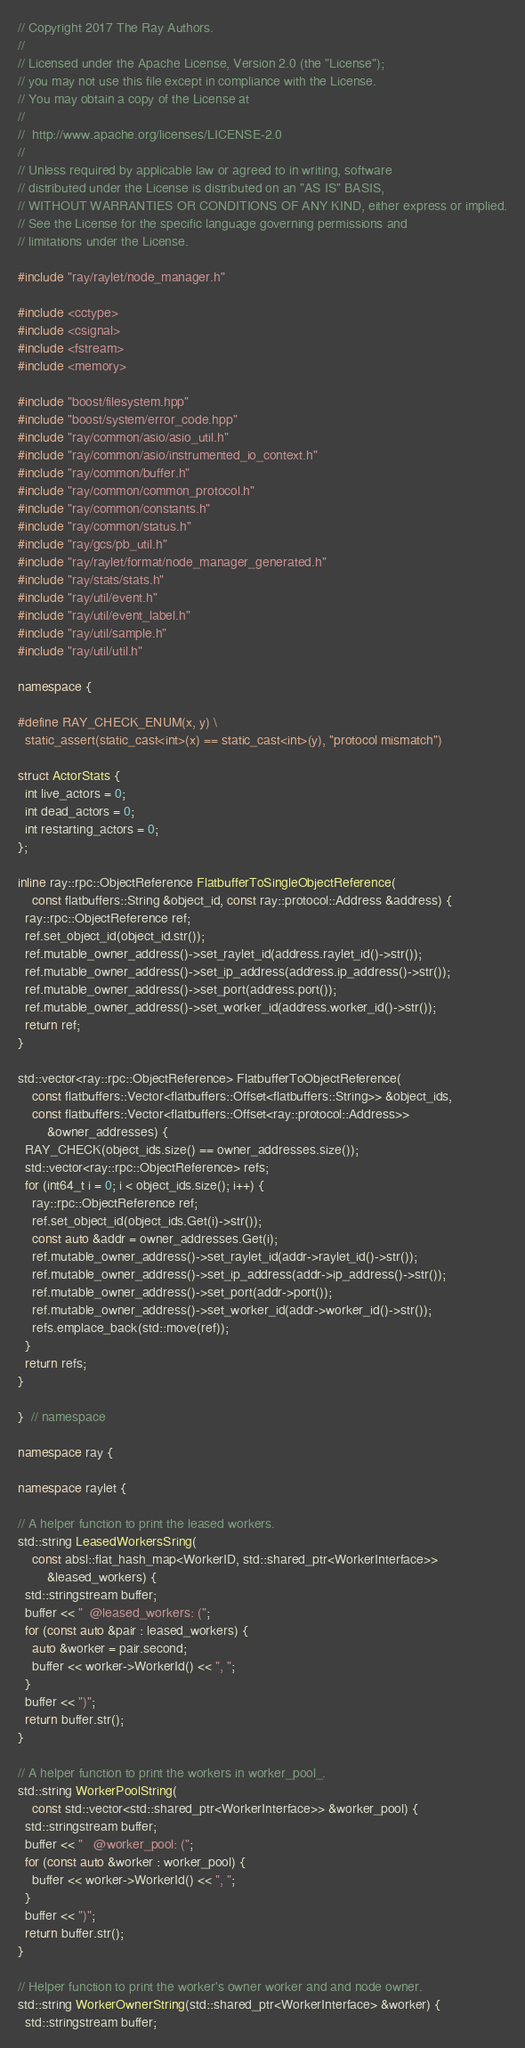<code> <loc_0><loc_0><loc_500><loc_500><_C++_>// Copyright 2017 The Ray Authors.
//
// Licensed under the Apache License, Version 2.0 (the "License");
// you may not use this file except in compliance with the License.
// You may obtain a copy of the License at
//
//  http://www.apache.org/licenses/LICENSE-2.0
//
// Unless required by applicable law or agreed to in writing, software
// distributed under the License is distributed on an "AS IS" BASIS,
// WITHOUT WARRANTIES OR CONDITIONS OF ANY KIND, either express or implied.
// See the License for the specific language governing permissions and
// limitations under the License.

#include "ray/raylet/node_manager.h"

#include <cctype>
#include <csignal>
#include <fstream>
#include <memory>

#include "boost/filesystem.hpp"
#include "boost/system/error_code.hpp"
#include "ray/common/asio/asio_util.h"
#include "ray/common/asio/instrumented_io_context.h"
#include "ray/common/buffer.h"
#include "ray/common/common_protocol.h"
#include "ray/common/constants.h"
#include "ray/common/status.h"
#include "ray/gcs/pb_util.h"
#include "ray/raylet/format/node_manager_generated.h"
#include "ray/stats/stats.h"
#include "ray/util/event.h"
#include "ray/util/event_label.h"
#include "ray/util/sample.h"
#include "ray/util/util.h"

namespace {

#define RAY_CHECK_ENUM(x, y) \
  static_assert(static_cast<int>(x) == static_cast<int>(y), "protocol mismatch")

struct ActorStats {
  int live_actors = 0;
  int dead_actors = 0;
  int restarting_actors = 0;
};

inline ray::rpc::ObjectReference FlatbufferToSingleObjectReference(
    const flatbuffers::String &object_id, const ray::protocol::Address &address) {
  ray::rpc::ObjectReference ref;
  ref.set_object_id(object_id.str());
  ref.mutable_owner_address()->set_raylet_id(address.raylet_id()->str());
  ref.mutable_owner_address()->set_ip_address(address.ip_address()->str());
  ref.mutable_owner_address()->set_port(address.port());
  ref.mutable_owner_address()->set_worker_id(address.worker_id()->str());
  return ref;
}

std::vector<ray::rpc::ObjectReference> FlatbufferToObjectReference(
    const flatbuffers::Vector<flatbuffers::Offset<flatbuffers::String>> &object_ids,
    const flatbuffers::Vector<flatbuffers::Offset<ray::protocol::Address>>
        &owner_addresses) {
  RAY_CHECK(object_ids.size() == owner_addresses.size());
  std::vector<ray::rpc::ObjectReference> refs;
  for (int64_t i = 0; i < object_ids.size(); i++) {
    ray::rpc::ObjectReference ref;
    ref.set_object_id(object_ids.Get(i)->str());
    const auto &addr = owner_addresses.Get(i);
    ref.mutable_owner_address()->set_raylet_id(addr->raylet_id()->str());
    ref.mutable_owner_address()->set_ip_address(addr->ip_address()->str());
    ref.mutable_owner_address()->set_port(addr->port());
    ref.mutable_owner_address()->set_worker_id(addr->worker_id()->str());
    refs.emplace_back(std::move(ref));
  }
  return refs;
}

}  // namespace

namespace ray {

namespace raylet {

// A helper function to print the leased workers.
std::string LeasedWorkersSring(
    const absl::flat_hash_map<WorkerID, std::shared_ptr<WorkerInterface>>
        &leased_workers) {
  std::stringstream buffer;
  buffer << "  @leased_workers: (";
  for (const auto &pair : leased_workers) {
    auto &worker = pair.second;
    buffer << worker->WorkerId() << ", ";
  }
  buffer << ")";
  return buffer.str();
}

// A helper function to print the workers in worker_pool_.
std::string WorkerPoolString(
    const std::vector<std::shared_ptr<WorkerInterface>> &worker_pool) {
  std::stringstream buffer;
  buffer << "   @worker_pool: (";
  for (const auto &worker : worker_pool) {
    buffer << worker->WorkerId() << ", ";
  }
  buffer << ")";
  return buffer.str();
}

// Helper function to print the worker's owner worker and and node owner.
std::string WorkerOwnerString(std::shared_ptr<WorkerInterface> &worker) {
  std::stringstream buffer;</code> 